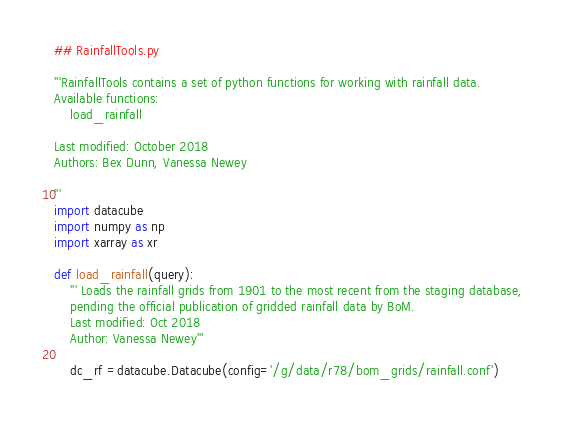Convert code to text. <code><loc_0><loc_0><loc_500><loc_500><_Python_>## RainfallTools.py

'''RainfallTools contains a set of python functions for working with rainfall data.
Available functions:
    load_rainfall
    
Last modified: October 2018
Authors: Bex Dunn, Vanessa Newey 
    
'''
import datacube
import numpy as np
import xarray as xr

def load_rainfall(query):
    ''' Loads the rainfall grids from 1901 to the most recent from the staging database,
    pending the official publication of gridded rainfall data by BoM. 
    Last modified: Oct 2018
    Author: Vanessa Newey'''
    
    dc_rf =datacube.Datacube(config='/g/data/r78/bom_grids/rainfall.conf')
    </code> 